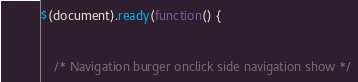Convert code to text. <code><loc_0><loc_0><loc_500><loc_500><_JavaScript_>$(document).ready(function() {

	
	/* Navigation burger onclick side navigation show */</code> 